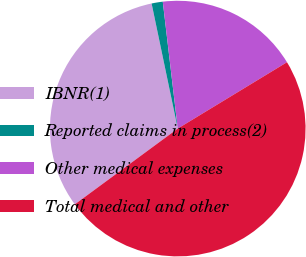Convert chart to OTSL. <chart><loc_0><loc_0><loc_500><loc_500><pie_chart><fcel>IBNR(1)<fcel>Reported claims in process(2)<fcel>Other medical expenses<fcel>Total medical and other<nl><fcel>31.82%<fcel>1.41%<fcel>18.18%<fcel>48.59%<nl></chart> 